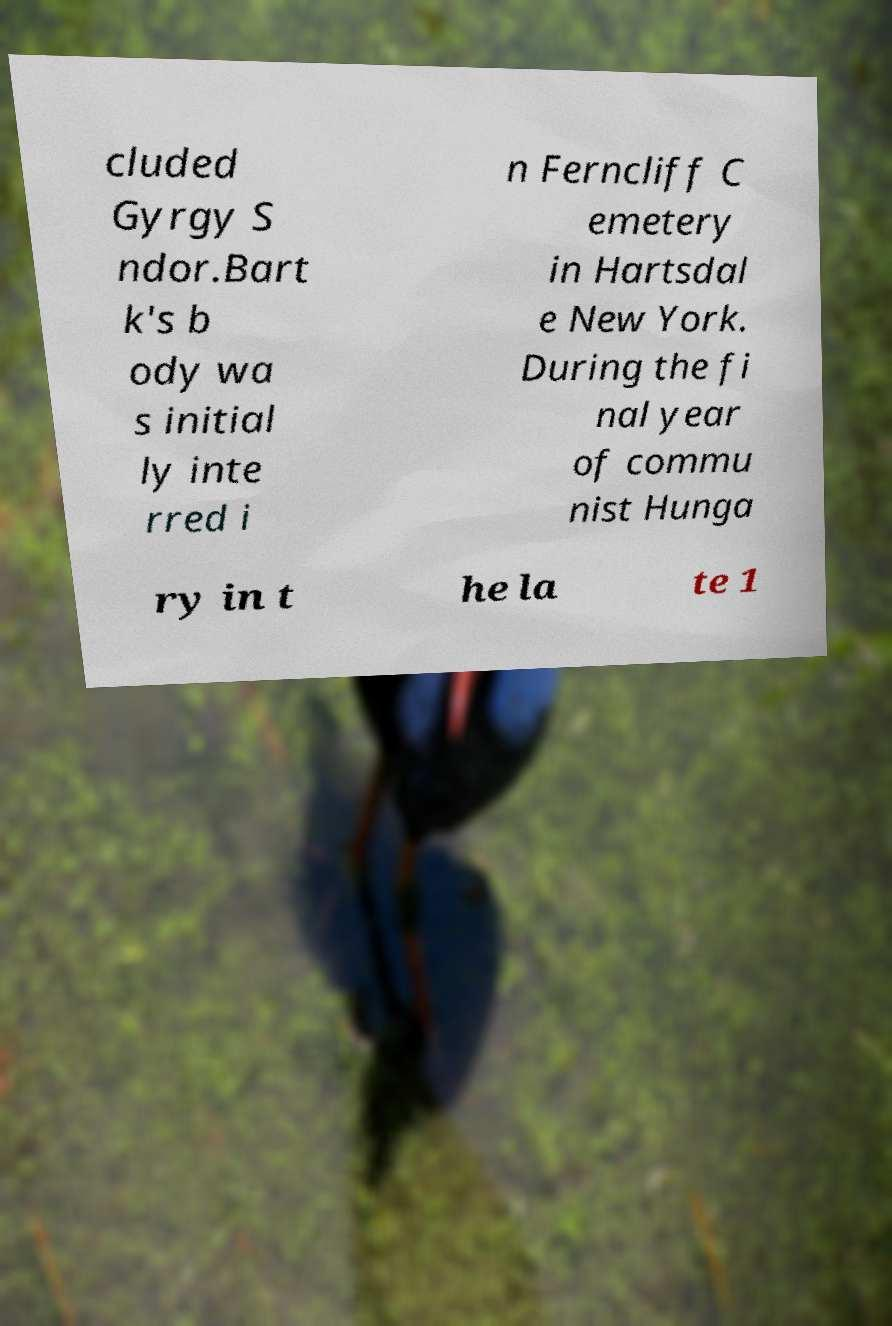Please identify and transcribe the text found in this image. cluded Gyrgy S ndor.Bart k's b ody wa s initial ly inte rred i n Ferncliff C emetery in Hartsdal e New York. During the fi nal year of commu nist Hunga ry in t he la te 1 